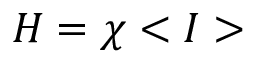Convert formula to latex. <formula><loc_0><loc_0><loc_500><loc_500>H = \chi < I ></formula> 